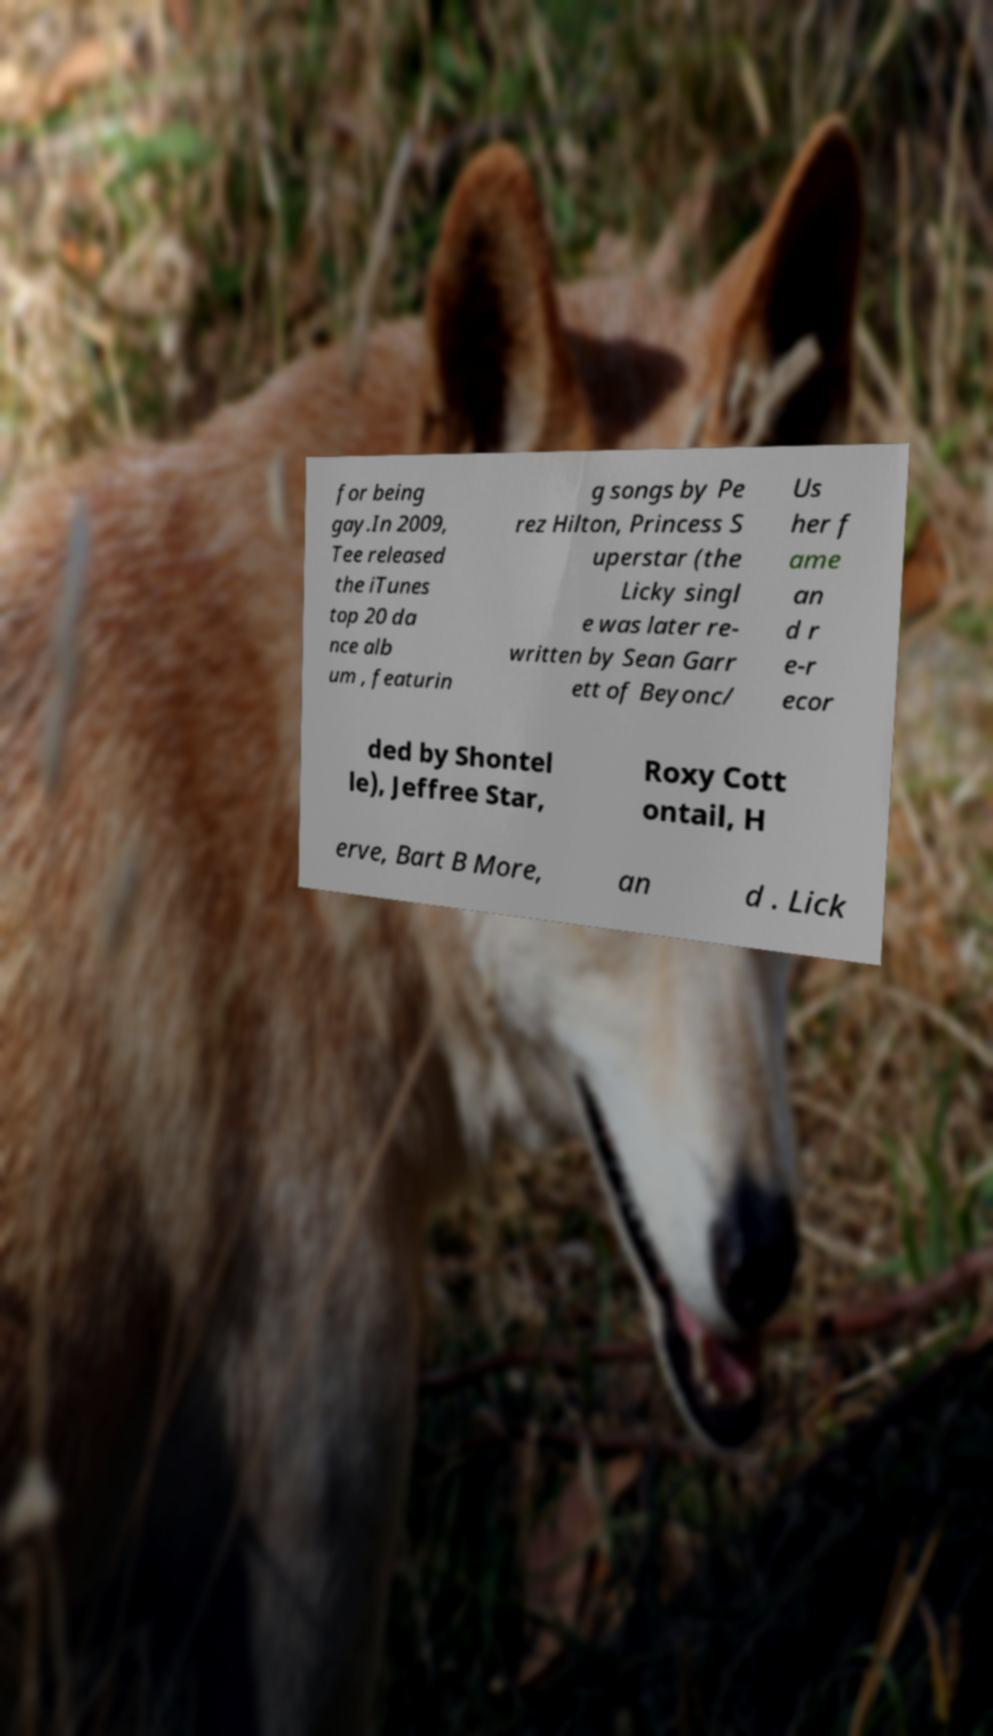I need the written content from this picture converted into text. Can you do that? for being gay.In 2009, Tee released the iTunes top 20 da nce alb um , featurin g songs by Pe rez Hilton, Princess S uperstar (the Licky singl e was later re- written by Sean Garr ett of Beyonc/ Us her f ame an d r e-r ecor ded by Shontel le), Jeffree Star, Roxy Cott ontail, H erve, Bart B More, an d . Lick 